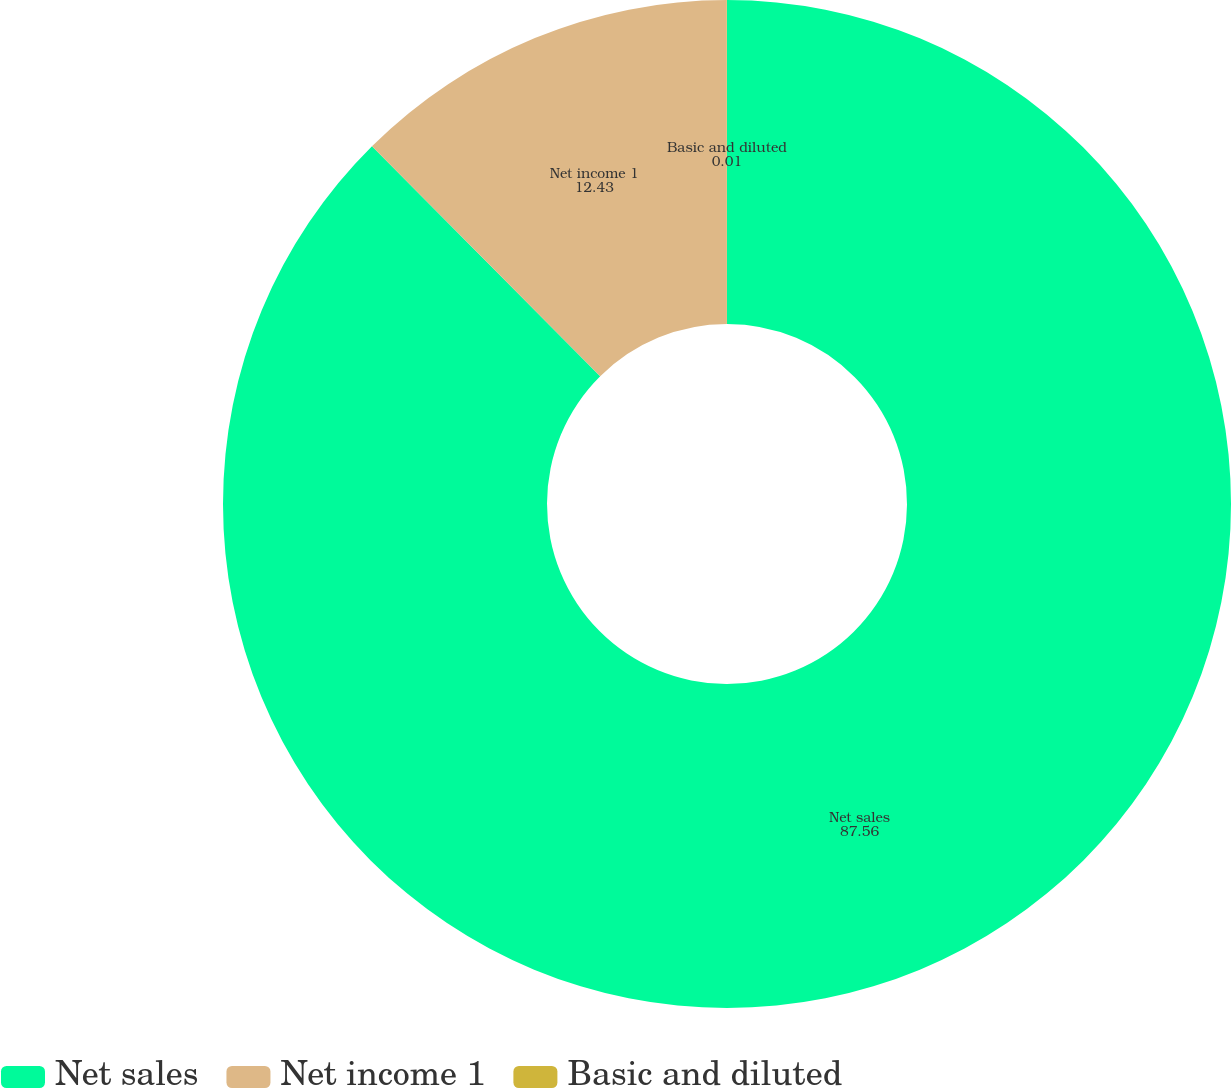Convert chart to OTSL. <chart><loc_0><loc_0><loc_500><loc_500><pie_chart><fcel>Net sales<fcel>Net income 1<fcel>Basic and diluted<nl><fcel>87.56%<fcel>12.43%<fcel>0.01%<nl></chart> 